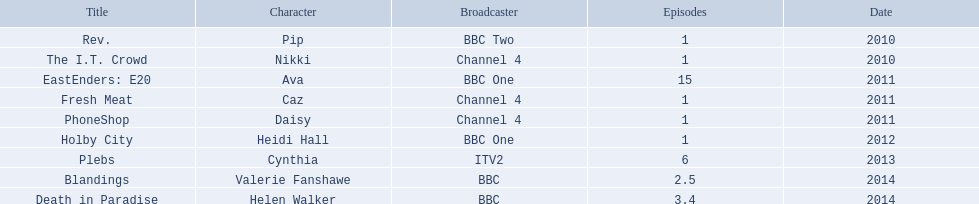Which characters were showcased in more than one episode? Ava, Cynthia, Valerie Fanshawe, Helen Walker. Who among them didn't appear in 2014? Ava, Cynthia. And who wasn't aired on a bbc channel? Cynthia. 